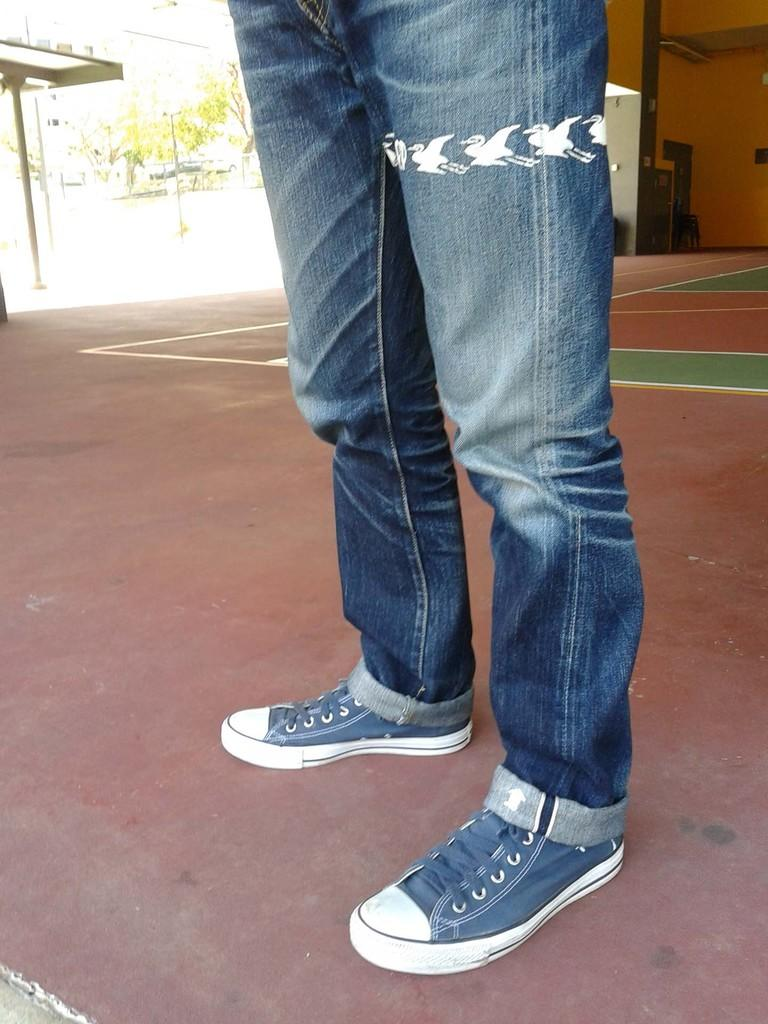Who or what is present in the image? There is a person in the image. What type of clothing is the person wearing? The person is wearing blue jeans. What kind of shoes is the person wearing? The person is wearing blue and white shoes. What can be seen in the background of the image? There are trees visible in the image. What type of magic is the person performing in the image? There is no indication of magic or any magical activity in the image. 